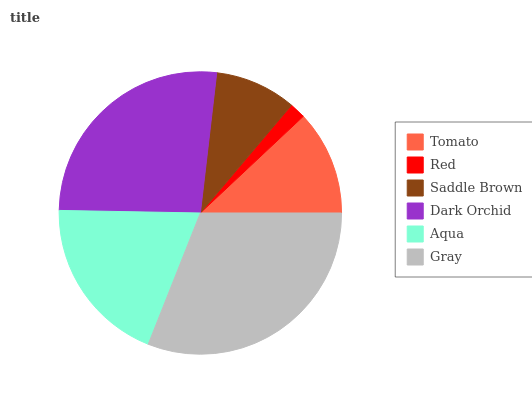Is Red the minimum?
Answer yes or no. Yes. Is Gray the maximum?
Answer yes or no. Yes. Is Saddle Brown the minimum?
Answer yes or no. No. Is Saddle Brown the maximum?
Answer yes or no. No. Is Saddle Brown greater than Red?
Answer yes or no. Yes. Is Red less than Saddle Brown?
Answer yes or no. Yes. Is Red greater than Saddle Brown?
Answer yes or no. No. Is Saddle Brown less than Red?
Answer yes or no. No. Is Aqua the high median?
Answer yes or no. Yes. Is Tomato the low median?
Answer yes or no. Yes. Is Saddle Brown the high median?
Answer yes or no. No. Is Gray the low median?
Answer yes or no. No. 